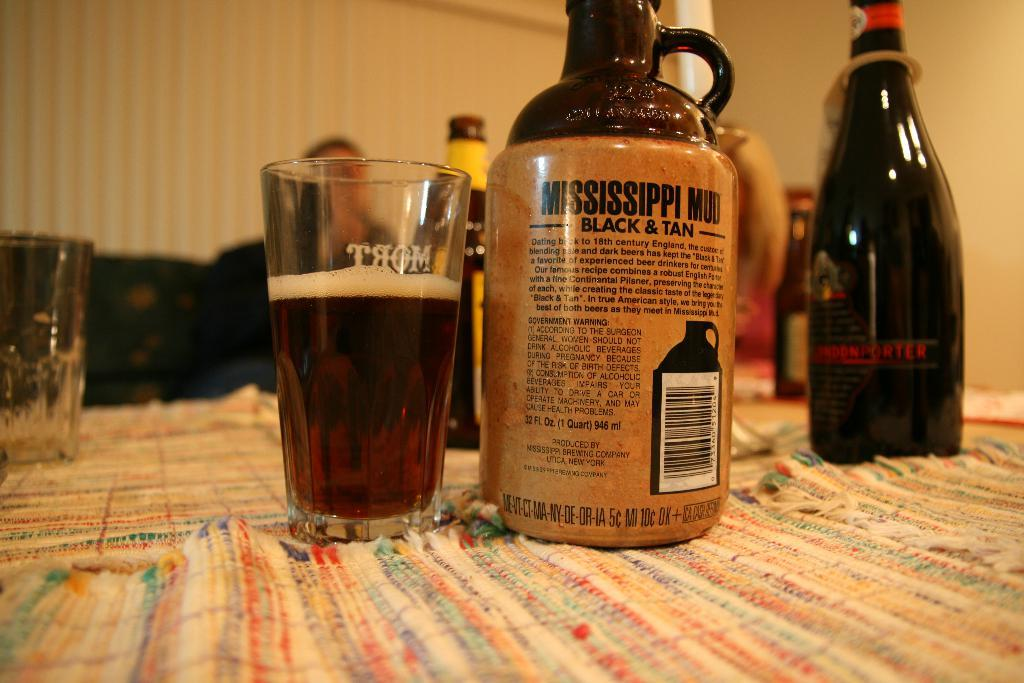Provide a one-sentence caption for the provided image. Jug of Mississippi Mud sits next to a glass full on a table with other bottles. 